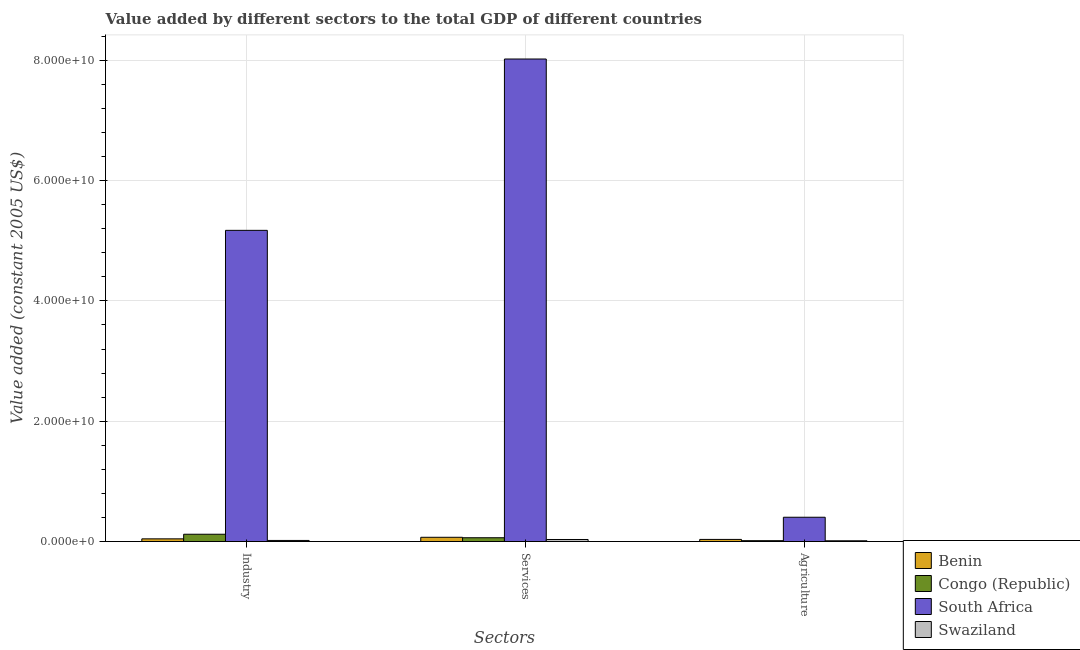How many different coloured bars are there?
Offer a very short reply. 4. How many bars are there on the 3rd tick from the left?
Make the answer very short. 4. How many bars are there on the 2nd tick from the right?
Your answer should be compact. 4. What is the label of the 3rd group of bars from the left?
Offer a very short reply. Agriculture. What is the value added by agricultural sector in South Africa?
Give a very brief answer. 4.04e+09. Across all countries, what is the maximum value added by industrial sector?
Give a very brief answer. 5.17e+1. Across all countries, what is the minimum value added by industrial sector?
Make the answer very short. 1.85e+08. In which country was the value added by agricultural sector maximum?
Your answer should be compact. South Africa. In which country was the value added by industrial sector minimum?
Ensure brevity in your answer.  Swaziland. What is the total value added by agricultural sector in the graph?
Ensure brevity in your answer.  4.68e+09. What is the difference between the value added by services in Congo (Republic) and that in Benin?
Your answer should be compact. -7.37e+07. What is the difference between the value added by agricultural sector in Congo (Republic) and the value added by services in Benin?
Make the answer very short. -5.61e+08. What is the average value added by services per country?
Your response must be concise. 2.05e+1. What is the difference between the value added by agricultural sector and value added by industrial sector in Swaziland?
Offer a terse response. -5.48e+07. What is the ratio of the value added by services in Benin to that in Swaziland?
Give a very brief answer. 2.06. What is the difference between the highest and the second highest value added by agricultural sector?
Ensure brevity in your answer.  3.68e+09. What is the difference between the highest and the lowest value added by services?
Offer a very short reply. 7.99e+1. In how many countries, is the value added by agricultural sector greater than the average value added by agricultural sector taken over all countries?
Provide a short and direct response. 1. Is the sum of the value added by services in Swaziland and Congo (Republic) greater than the maximum value added by industrial sector across all countries?
Provide a succinct answer. No. What does the 3rd bar from the left in Agriculture represents?
Give a very brief answer. South Africa. What does the 2nd bar from the right in Services represents?
Your answer should be compact. South Africa. Does the graph contain any zero values?
Provide a succinct answer. No. Does the graph contain grids?
Provide a succinct answer. Yes. What is the title of the graph?
Ensure brevity in your answer.  Value added by different sectors to the total GDP of different countries. Does "Latvia" appear as one of the legend labels in the graph?
Offer a terse response. No. What is the label or title of the X-axis?
Give a very brief answer. Sectors. What is the label or title of the Y-axis?
Your answer should be compact. Value added (constant 2005 US$). What is the Value added (constant 2005 US$) of Benin in Industry?
Keep it short and to the point. 4.52e+08. What is the Value added (constant 2005 US$) of Congo (Republic) in Industry?
Your answer should be compact. 1.22e+09. What is the Value added (constant 2005 US$) in South Africa in Industry?
Ensure brevity in your answer.  5.17e+1. What is the Value added (constant 2005 US$) in Swaziland in Industry?
Give a very brief answer. 1.85e+08. What is the Value added (constant 2005 US$) of Benin in Services?
Give a very brief answer. 7.09e+08. What is the Value added (constant 2005 US$) of Congo (Republic) in Services?
Offer a very short reply. 6.35e+08. What is the Value added (constant 2005 US$) of South Africa in Services?
Ensure brevity in your answer.  8.02e+1. What is the Value added (constant 2005 US$) of Swaziland in Services?
Ensure brevity in your answer.  3.44e+08. What is the Value added (constant 2005 US$) in Benin in Agriculture?
Keep it short and to the point. 3.58e+08. What is the Value added (constant 2005 US$) in Congo (Republic) in Agriculture?
Your response must be concise. 1.48e+08. What is the Value added (constant 2005 US$) of South Africa in Agriculture?
Provide a short and direct response. 4.04e+09. What is the Value added (constant 2005 US$) in Swaziland in Agriculture?
Give a very brief answer. 1.30e+08. Across all Sectors, what is the maximum Value added (constant 2005 US$) in Benin?
Offer a very short reply. 7.09e+08. Across all Sectors, what is the maximum Value added (constant 2005 US$) of Congo (Republic)?
Ensure brevity in your answer.  1.22e+09. Across all Sectors, what is the maximum Value added (constant 2005 US$) of South Africa?
Make the answer very short. 8.02e+1. Across all Sectors, what is the maximum Value added (constant 2005 US$) of Swaziland?
Your answer should be compact. 3.44e+08. Across all Sectors, what is the minimum Value added (constant 2005 US$) in Benin?
Make the answer very short. 3.58e+08. Across all Sectors, what is the minimum Value added (constant 2005 US$) in Congo (Republic)?
Keep it short and to the point. 1.48e+08. Across all Sectors, what is the minimum Value added (constant 2005 US$) of South Africa?
Your answer should be compact. 4.04e+09. Across all Sectors, what is the minimum Value added (constant 2005 US$) of Swaziland?
Offer a terse response. 1.30e+08. What is the total Value added (constant 2005 US$) of Benin in the graph?
Your response must be concise. 1.52e+09. What is the total Value added (constant 2005 US$) in Congo (Republic) in the graph?
Offer a terse response. 2.00e+09. What is the total Value added (constant 2005 US$) in South Africa in the graph?
Provide a succinct answer. 1.36e+11. What is the total Value added (constant 2005 US$) in Swaziland in the graph?
Your response must be concise. 6.58e+08. What is the difference between the Value added (constant 2005 US$) in Benin in Industry and that in Services?
Make the answer very short. -2.58e+08. What is the difference between the Value added (constant 2005 US$) of Congo (Republic) in Industry and that in Services?
Your response must be concise. 5.82e+08. What is the difference between the Value added (constant 2005 US$) of South Africa in Industry and that in Services?
Offer a very short reply. -2.85e+1. What is the difference between the Value added (constant 2005 US$) in Swaziland in Industry and that in Services?
Ensure brevity in your answer.  -1.59e+08. What is the difference between the Value added (constant 2005 US$) of Benin in Industry and that in Agriculture?
Offer a very short reply. 9.39e+07. What is the difference between the Value added (constant 2005 US$) in Congo (Republic) in Industry and that in Agriculture?
Provide a succinct answer. 1.07e+09. What is the difference between the Value added (constant 2005 US$) in South Africa in Industry and that in Agriculture?
Provide a succinct answer. 4.77e+1. What is the difference between the Value added (constant 2005 US$) of Swaziland in Industry and that in Agriculture?
Your answer should be compact. 5.48e+07. What is the difference between the Value added (constant 2005 US$) in Benin in Services and that in Agriculture?
Give a very brief answer. 3.51e+08. What is the difference between the Value added (constant 2005 US$) in Congo (Republic) in Services and that in Agriculture?
Your answer should be compact. 4.88e+08. What is the difference between the Value added (constant 2005 US$) in South Africa in Services and that in Agriculture?
Your answer should be very brief. 7.62e+1. What is the difference between the Value added (constant 2005 US$) in Swaziland in Services and that in Agriculture?
Your answer should be compact. 2.14e+08. What is the difference between the Value added (constant 2005 US$) in Benin in Industry and the Value added (constant 2005 US$) in Congo (Republic) in Services?
Make the answer very short. -1.84e+08. What is the difference between the Value added (constant 2005 US$) in Benin in Industry and the Value added (constant 2005 US$) in South Africa in Services?
Offer a very short reply. -7.97e+1. What is the difference between the Value added (constant 2005 US$) in Benin in Industry and the Value added (constant 2005 US$) in Swaziland in Services?
Keep it short and to the point. 1.08e+08. What is the difference between the Value added (constant 2005 US$) of Congo (Republic) in Industry and the Value added (constant 2005 US$) of South Africa in Services?
Offer a very short reply. -7.90e+1. What is the difference between the Value added (constant 2005 US$) of Congo (Republic) in Industry and the Value added (constant 2005 US$) of Swaziland in Services?
Your answer should be very brief. 8.74e+08. What is the difference between the Value added (constant 2005 US$) of South Africa in Industry and the Value added (constant 2005 US$) of Swaziland in Services?
Offer a very short reply. 5.14e+1. What is the difference between the Value added (constant 2005 US$) in Benin in Industry and the Value added (constant 2005 US$) in Congo (Republic) in Agriculture?
Ensure brevity in your answer.  3.04e+08. What is the difference between the Value added (constant 2005 US$) of Benin in Industry and the Value added (constant 2005 US$) of South Africa in Agriculture?
Provide a short and direct response. -3.59e+09. What is the difference between the Value added (constant 2005 US$) of Benin in Industry and the Value added (constant 2005 US$) of Swaziland in Agriculture?
Keep it short and to the point. 3.22e+08. What is the difference between the Value added (constant 2005 US$) of Congo (Republic) in Industry and the Value added (constant 2005 US$) of South Africa in Agriculture?
Give a very brief answer. -2.82e+09. What is the difference between the Value added (constant 2005 US$) of Congo (Republic) in Industry and the Value added (constant 2005 US$) of Swaziland in Agriculture?
Your response must be concise. 1.09e+09. What is the difference between the Value added (constant 2005 US$) in South Africa in Industry and the Value added (constant 2005 US$) in Swaziland in Agriculture?
Provide a succinct answer. 5.16e+1. What is the difference between the Value added (constant 2005 US$) of Benin in Services and the Value added (constant 2005 US$) of Congo (Republic) in Agriculture?
Your answer should be compact. 5.61e+08. What is the difference between the Value added (constant 2005 US$) in Benin in Services and the Value added (constant 2005 US$) in South Africa in Agriculture?
Your answer should be very brief. -3.33e+09. What is the difference between the Value added (constant 2005 US$) of Benin in Services and the Value added (constant 2005 US$) of Swaziland in Agriculture?
Ensure brevity in your answer.  5.79e+08. What is the difference between the Value added (constant 2005 US$) in Congo (Republic) in Services and the Value added (constant 2005 US$) in South Africa in Agriculture?
Provide a succinct answer. -3.41e+09. What is the difference between the Value added (constant 2005 US$) of Congo (Republic) in Services and the Value added (constant 2005 US$) of Swaziland in Agriculture?
Offer a very short reply. 5.06e+08. What is the difference between the Value added (constant 2005 US$) of South Africa in Services and the Value added (constant 2005 US$) of Swaziland in Agriculture?
Offer a terse response. 8.01e+1. What is the average Value added (constant 2005 US$) of Benin per Sectors?
Offer a terse response. 5.06e+08. What is the average Value added (constant 2005 US$) of Congo (Republic) per Sectors?
Your answer should be very brief. 6.67e+08. What is the average Value added (constant 2005 US$) of South Africa per Sectors?
Offer a very short reply. 4.53e+1. What is the average Value added (constant 2005 US$) in Swaziland per Sectors?
Provide a succinct answer. 2.19e+08. What is the difference between the Value added (constant 2005 US$) in Benin and Value added (constant 2005 US$) in Congo (Republic) in Industry?
Your answer should be very brief. -7.66e+08. What is the difference between the Value added (constant 2005 US$) in Benin and Value added (constant 2005 US$) in South Africa in Industry?
Provide a succinct answer. -5.13e+1. What is the difference between the Value added (constant 2005 US$) of Benin and Value added (constant 2005 US$) of Swaziland in Industry?
Your response must be concise. 2.67e+08. What is the difference between the Value added (constant 2005 US$) of Congo (Republic) and Value added (constant 2005 US$) of South Africa in Industry?
Your answer should be compact. -5.05e+1. What is the difference between the Value added (constant 2005 US$) of Congo (Republic) and Value added (constant 2005 US$) of Swaziland in Industry?
Keep it short and to the point. 1.03e+09. What is the difference between the Value added (constant 2005 US$) in South Africa and Value added (constant 2005 US$) in Swaziland in Industry?
Your response must be concise. 5.15e+1. What is the difference between the Value added (constant 2005 US$) of Benin and Value added (constant 2005 US$) of Congo (Republic) in Services?
Keep it short and to the point. 7.37e+07. What is the difference between the Value added (constant 2005 US$) of Benin and Value added (constant 2005 US$) of South Africa in Services?
Provide a succinct answer. -7.95e+1. What is the difference between the Value added (constant 2005 US$) of Benin and Value added (constant 2005 US$) of Swaziland in Services?
Offer a terse response. 3.65e+08. What is the difference between the Value added (constant 2005 US$) in Congo (Republic) and Value added (constant 2005 US$) in South Africa in Services?
Your answer should be compact. -7.96e+1. What is the difference between the Value added (constant 2005 US$) in Congo (Republic) and Value added (constant 2005 US$) in Swaziland in Services?
Your answer should be very brief. 2.92e+08. What is the difference between the Value added (constant 2005 US$) in South Africa and Value added (constant 2005 US$) in Swaziland in Services?
Your response must be concise. 7.99e+1. What is the difference between the Value added (constant 2005 US$) in Benin and Value added (constant 2005 US$) in Congo (Republic) in Agriculture?
Provide a short and direct response. 2.10e+08. What is the difference between the Value added (constant 2005 US$) in Benin and Value added (constant 2005 US$) in South Africa in Agriculture?
Offer a terse response. -3.68e+09. What is the difference between the Value added (constant 2005 US$) of Benin and Value added (constant 2005 US$) of Swaziland in Agriculture?
Your response must be concise. 2.28e+08. What is the difference between the Value added (constant 2005 US$) in Congo (Republic) and Value added (constant 2005 US$) in South Africa in Agriculture?
Your response must be concise. -3.89e+09. What is the difference between the Value added (constant 2005 US$) in Congo (Republic) and Value added (constant 2005 US$) in Swaziland in Agriculture?
Your response must be concise. 1.79e+07. What is the difference between the Value added (constant 2005 US$) in South Africa and Value added (constant 2005 US$) in Swaziland in Agriculture?
Your answer should be compact. 3.91e+09. What is the ratio of the Value added (constant 2005 US$) in Benin in Industry to that in Services?
Give a very brief answer. 0.64. What is the ratio of the Value added (constant 2005 US$) in Congo (Republic) in Industry to that in Services?
Offer a terse response. 1.92. What is the ratio of the Value added (constant 2005 US$) of South Africa in Industry to that in Services?
Provide a short and direct response. 0.64. What is the ratio of the Value added (constant 2005 US$) of Swaziland in Industry to that in Services?
Your answer should be compact. 0.54. What is the ratio of the Value added (constant 2005 US$) of Benin in Industry to that in Agriculture?
Give a very brief answer. 1.26. What is the ratio of the Value added (constant 2005 US$) of Congo (Republic) in Industry to that in Agriculture?
Provide a short and direct response. 8.24. What is the ratio of the Value added (constant 2005 US$) of South Africa in Industry to that in Agriculture?
Provide a short and direct response. 12.8. What is the ratio of the Value added (constant 2005 US$) of Swaziland in Industry to that in Agriculture?
Your answer should be very brief. 1.42. What is the ratio of the Value added (constant 2005 US$) in Benin in Services to that in Agriculture?
Ensure brevity in your answer.  1.98. What is the ratio of the Value added (constant 2005 US$) of Congo (Republic) in Services to that in Agriculture?
Offer a terse response. 4.3. What is the ratio of the Value added (constant 2005 US$) in South Africa in Services to that in Agriculture?
Keep it short and to the point. 19.84. What is the ratio of the Value added (constant 2005 US$) of Swaziland in Services to that in Agriculture?
Make the answer very short. 2.65. What is the difference between the highest and the second highest Value added (constant 2005 US$) of Benin?
Keep it short and to the point. 2.58e+08. What is the difference between the highest and the second highest Value added (constant 2005 US$) in Congo (Republic)?
Keep it short and to the point. 5.82e+08. What is the difference between the highest and the second highest Value added (constant 2005 US$) in South Africa?
Your response must be concise. 2.85e+1. What is the difference between the highest and the second highest Value added (constant 2005 US$) of Swaziland?
Provide a succinct answer. 1.59e+08. What is the difference between the highest and the lowest Value added (constant 2005 US$) of Benin?
Ensure brevity in your answer.  3.51e+08. What is the difference between the highest and the lowest Value added (constant 2005 US$) in Congo (Republic)?
Give a very brief answer. 1.07e+09. What is the difference between the highest and the lowest Value added (constant 2005 US$) in South Africa?
Give a very brief answer. 7.62e+1. What is the difference between the highest and the lowest Value added (constant 2005 US$) of Swaziland?
Offer a terse response. 2.14e+08. 